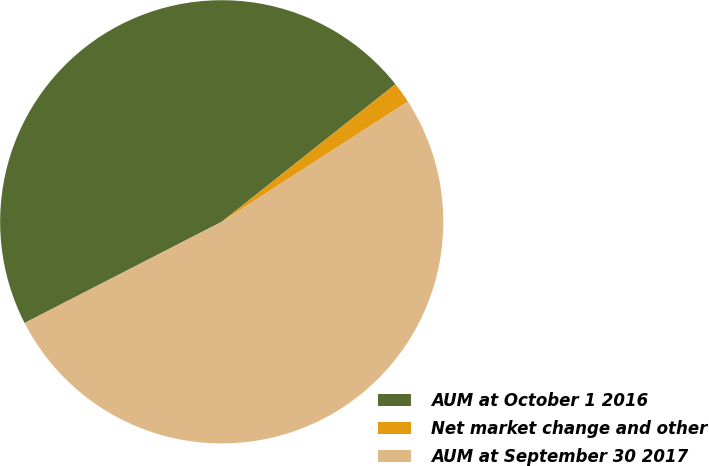Convert chart to OTSL. <chart><loc_0><loc_0><loc_500><loc_500><pie_chart><fcel>AUM at October 1 2016<fcel>Net market change and other<fcel>AUM at September 30 2017<nl><fcel>46.89%<fcel>1.54%<fcel>51.58%<nl></chart> 